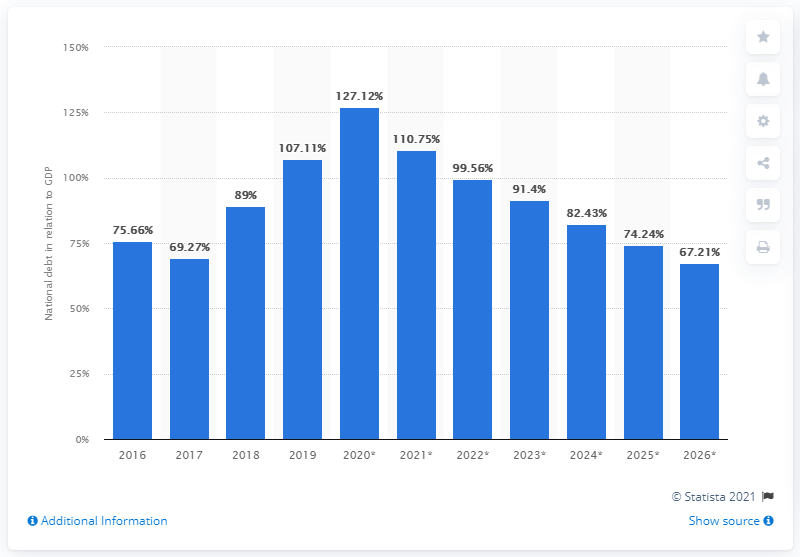Give some essential details in this illustration. In 2019, the national debt of Angola accounted for approximately 107.11% of the country's GDP. 